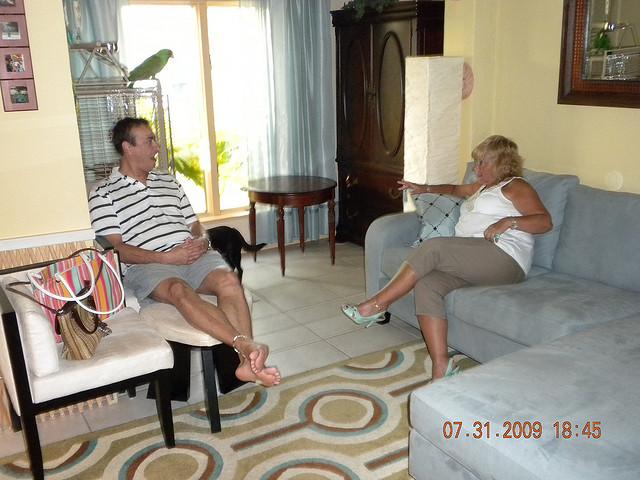Is the woman angry?
Keep it brief. No. Is the man wearing shoes?
Write a very short answer. No. Is this woman wearing an ankle bracelet?
Concise answer only. Yes. 